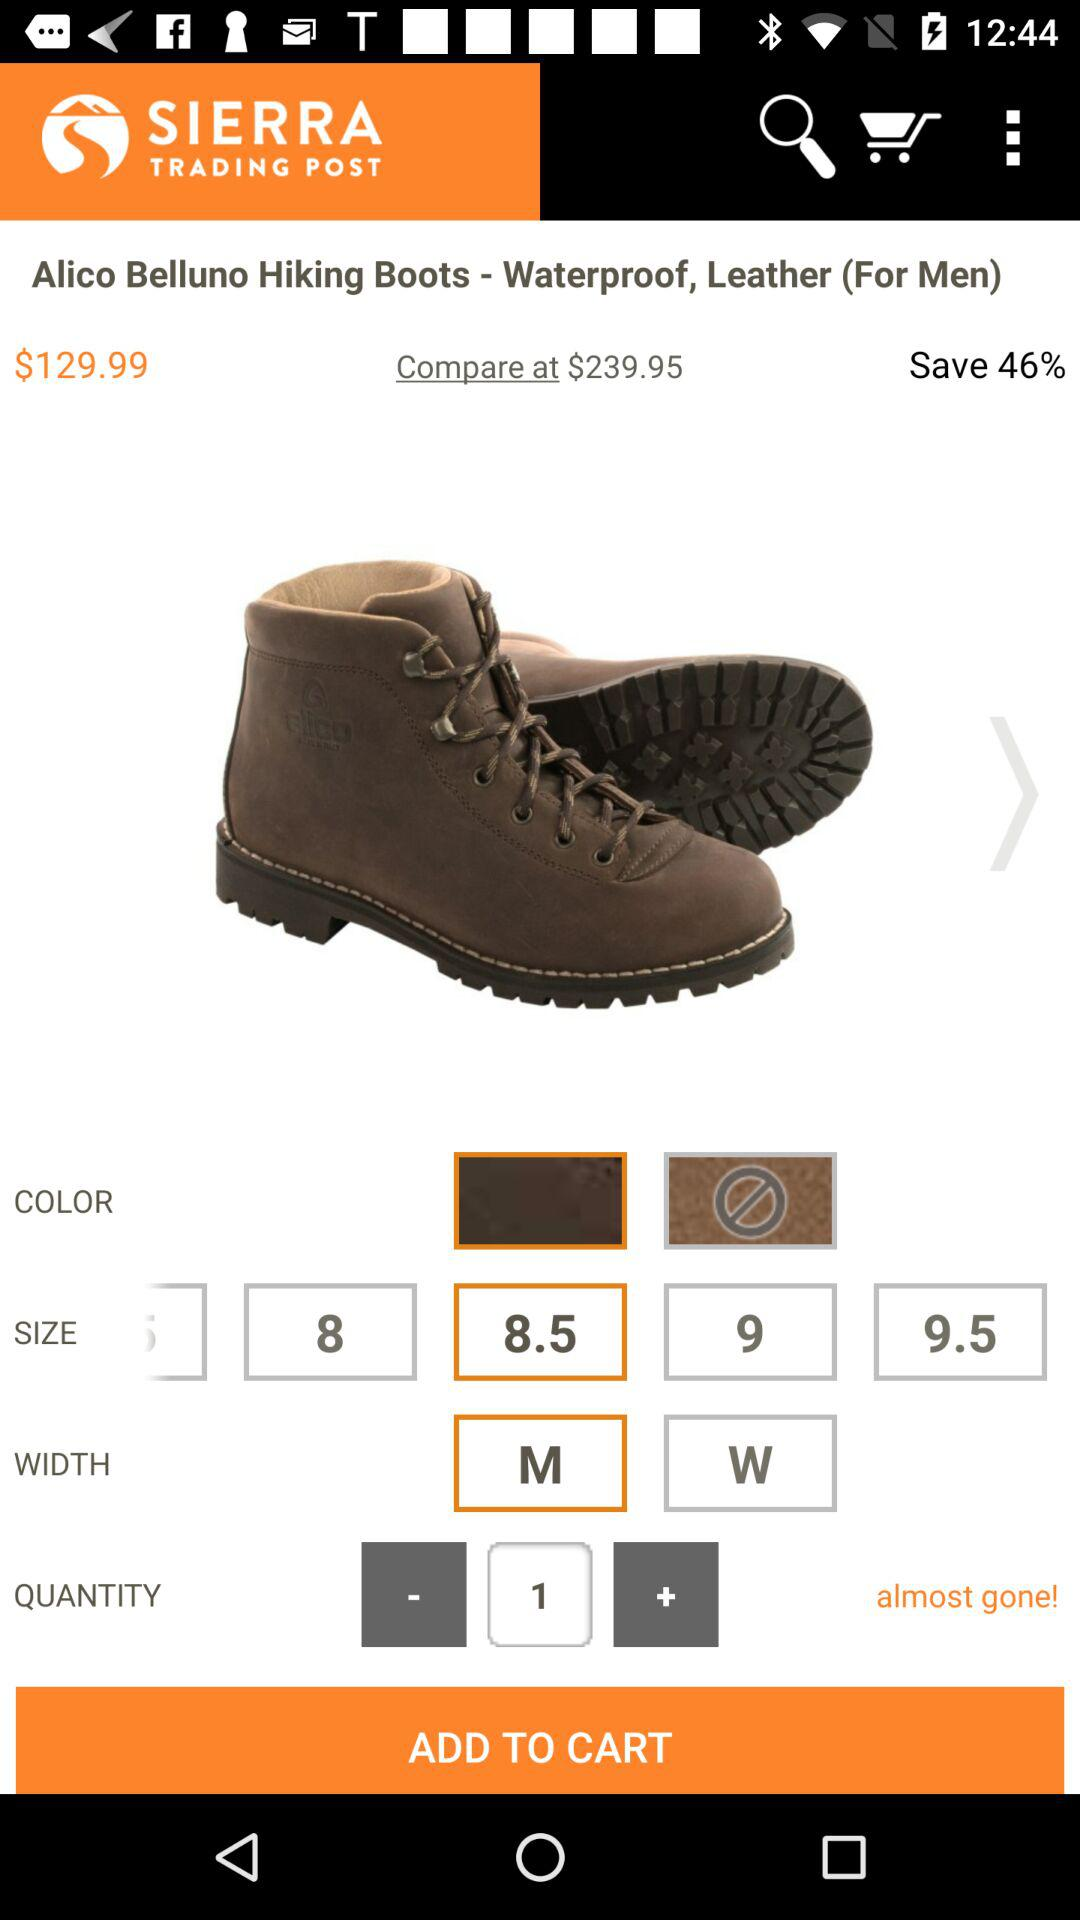What is the price of the product? The price of the product is $129.99. 